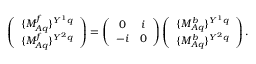Convert formula to latex. <formula><loc_0><loc_0><loc_500><loc_500>\left ( \begin{array} { c } { { \{ M _ { A q } ^ { f } \} ^ { Y ^ { 1 } q } } } \\ { { \{ M _ { A q } ^ { f } \} ^ { Y ^ { 2 } q } } } \end{array} \right ) = \left ( \begin{array} { c c } { 0 } & { i } \\ { - i } & { 0 } \end{array} \right ) \left ( \begin{array} { c } { { \{ M _ { A q } ^ { b } \} ^ { Y ^ { 1 } q } } } \\ { { \{ M _ { A q } ^ { b } \} ^ { Y ^ { 2 } q } } } \end{array} \right ) .</formula> 